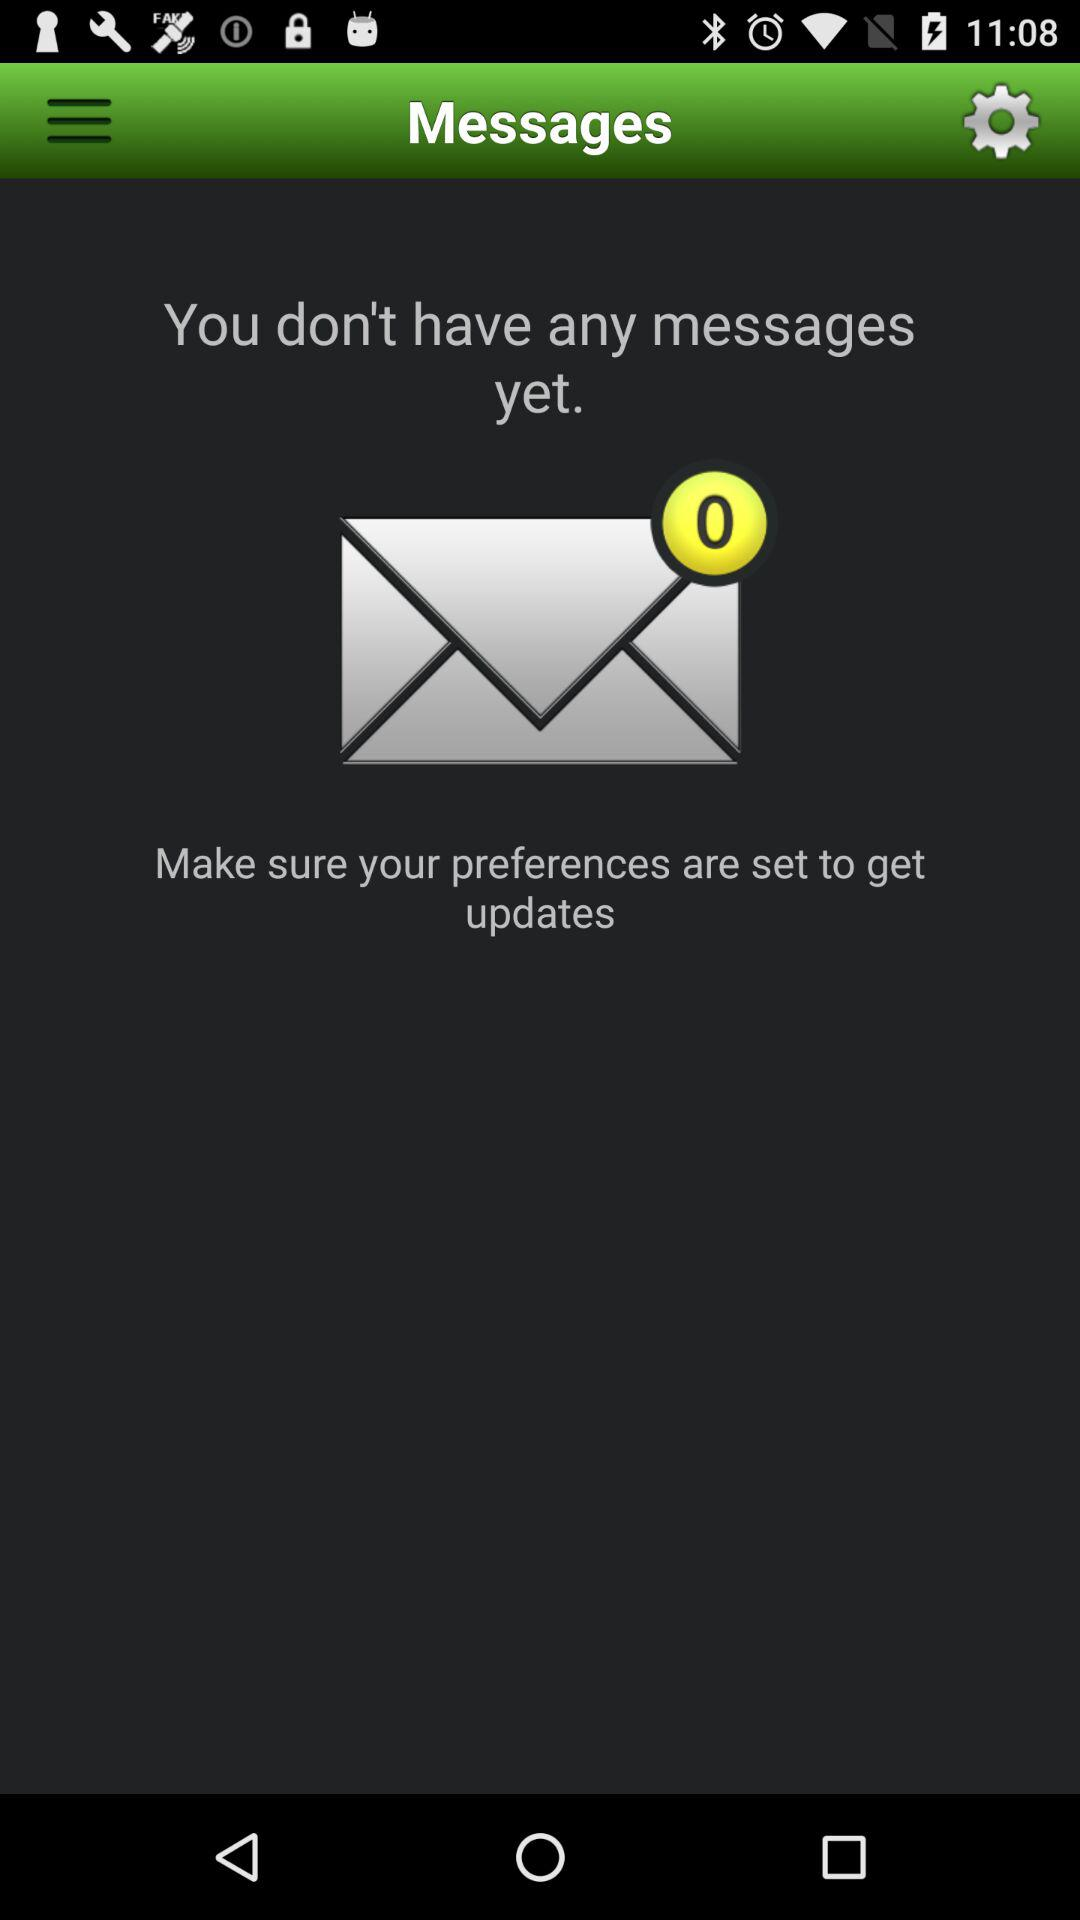Is there any messages to read? You don't have any messages to read. 